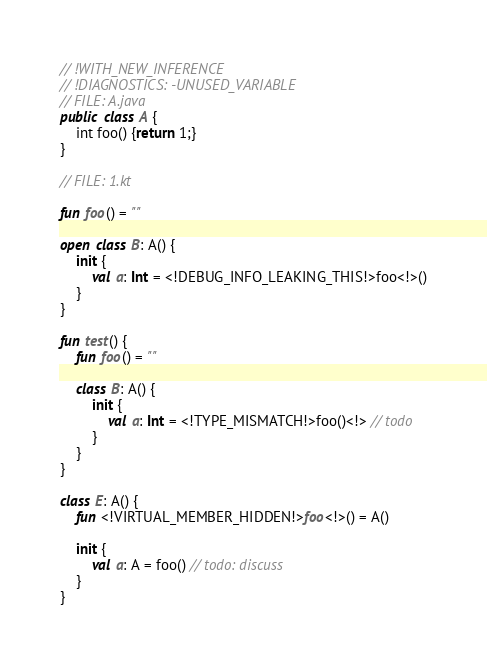Convert code to text. <code><loc_0><loc_0><loc_500><loc_500><_Kotlin_>// !WITH_NEW_INFERENCE
// !DIAGNOSTICS: -UNUSED_VARIABLE
// FILE: A.java
public class A {
    int foo() {return 1;}
}

// FILE: 1.kt

fun foo() = ""

open class B: A() {
    init {
        val a: Int = <!DEBUG_INFO_LEAKING_THIS!>foo<!>()
    }
}

fun test() {
    fun foo() = ""

    class B: A() {
        init {
            val a: Int = <!TYPE_MISMATCH!>foo()<!> // todo
        }
    }
}

class E: A() {
    fun <!VIRTUAL_MEMBER_HIDDEN!>foo<!>() = A()

    init {
        val a: A = foo() // todo: discuss
    }
}</code> 